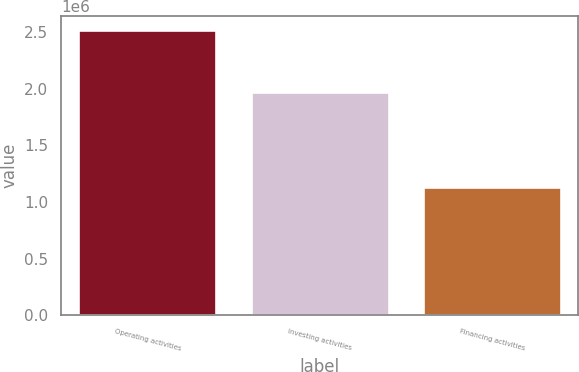Convert chart to OTSL. <chart><loc_0><loc_0><loc_500><loc_500><bar_chart><fcel>Operating activities<fcel>Investing activities<fcel>Financing activities<nl><fcel>2.51784e+06<fcel>1.97527e+06<fcel>1.13454e+06<nl></chart> 